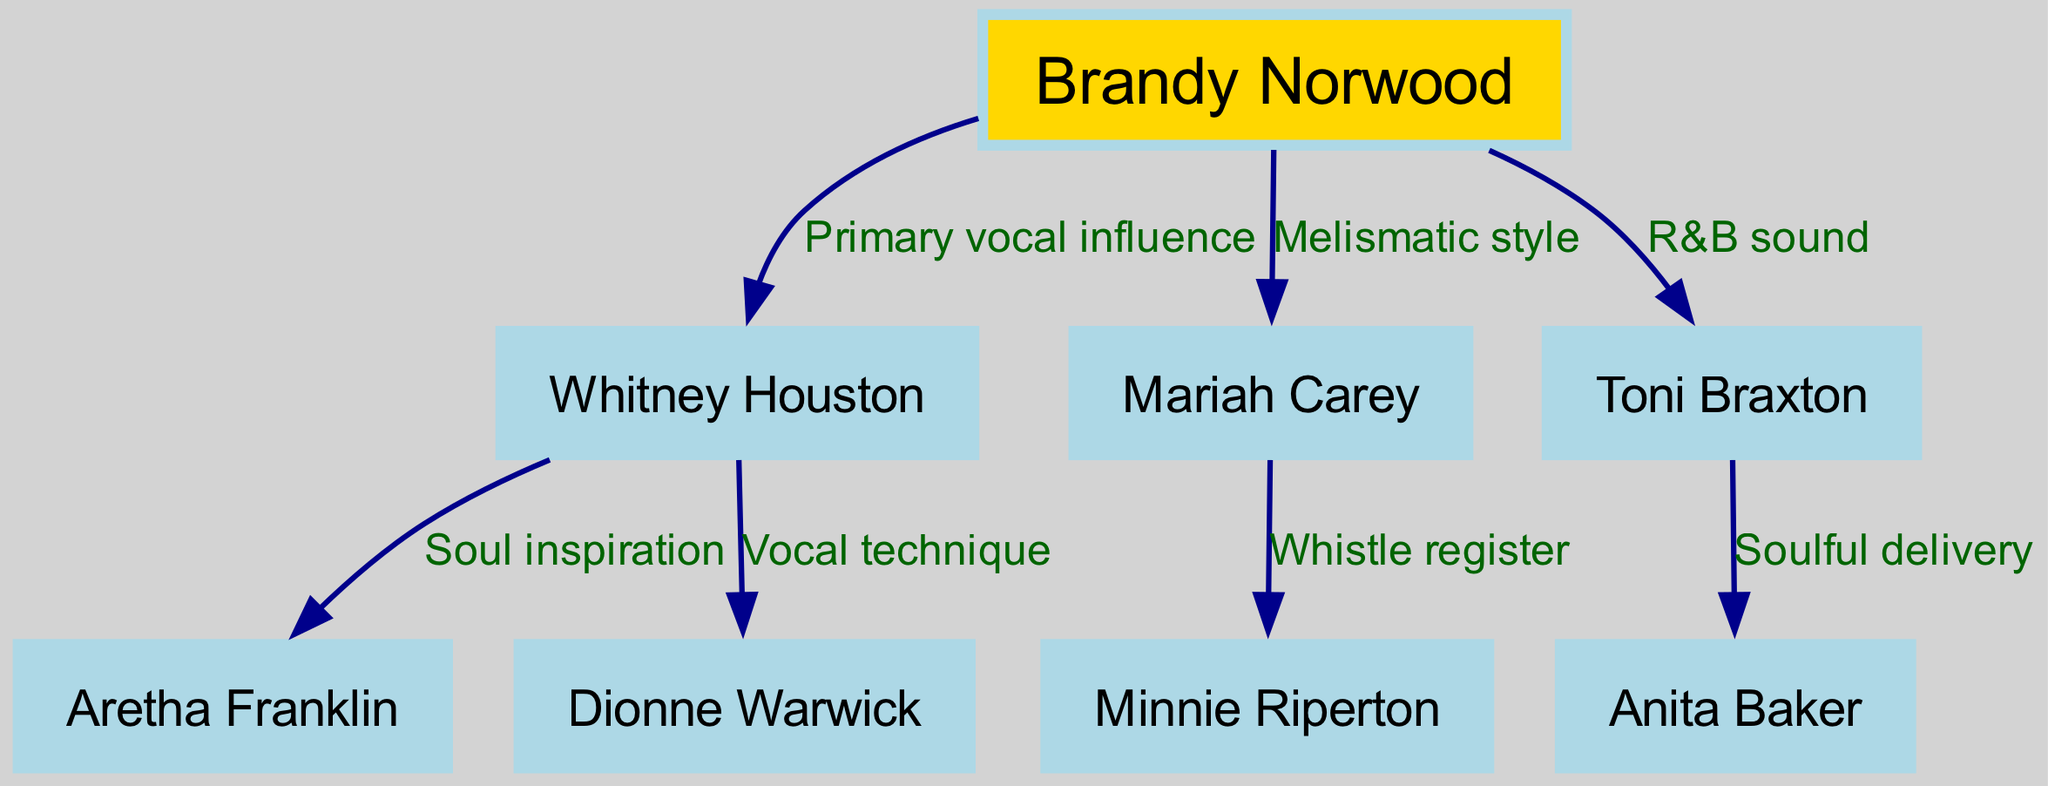What is Brandy Norwood's primary vocal influence? The diagram indicates that Whitney Houston is labeled as "Primary vocal influence," directly connected to Brandy Norwood.
Answer: Whitney Houston How many vocal influences does Brandy Norwood have listed in the diagram? By counting the nodes connected to Brandy Norwood, there are three primary influences: Whitney Houston, Mariah Carey, and Toni Braxton.
Answer: 3 Who is the influence connected to Whitney Houston that is noted for "Vocal technique"? The diagram shows that Dionne Warwick is connected to Whitney Houston and is labeled for her vocal technique.
Answer: Dionne Warwick Which artist is associated with "Soulful delivery"? Within the influences under Toni Braxton, Anita Baker is described as providing "Soulful delivery."
Answer: Anita Baker What is Mariah Carey's noted vocal style influence? The diagram specifies that Mariah Carey is linked to a "Melismatic style," outlining her unique approach to singing.
Answer: Melismatic style Which influence of Whitney Houston is recognized for their "Soul inspiration"? The diagram shows Aretha Franklin as the artist connected to Whitney Houston and is noted for providing "Soul inspiration."
Answer: Aretha Franklin Identify the artist who is known for the "Whistle register". In the diagram, Minnie Riperton is explicitly connected to Mariah Carey and noted as the influence for the "Whistle register."
Answer: Minnie Riperton What is the connection between Toni Braxton and Anita Baker? The diagram indicates that Toni Braxton is directly connected to Anita Baker, who influences her with "Soulful delivery."
Answer: Soulful delivery Which influence primarily contributes to Brandy Norwood's R&B sound? According to the diagram, Toni Braxton is specified as an influence for Brandy Norwood's R&B sound.
Answer: Toni Braxton 